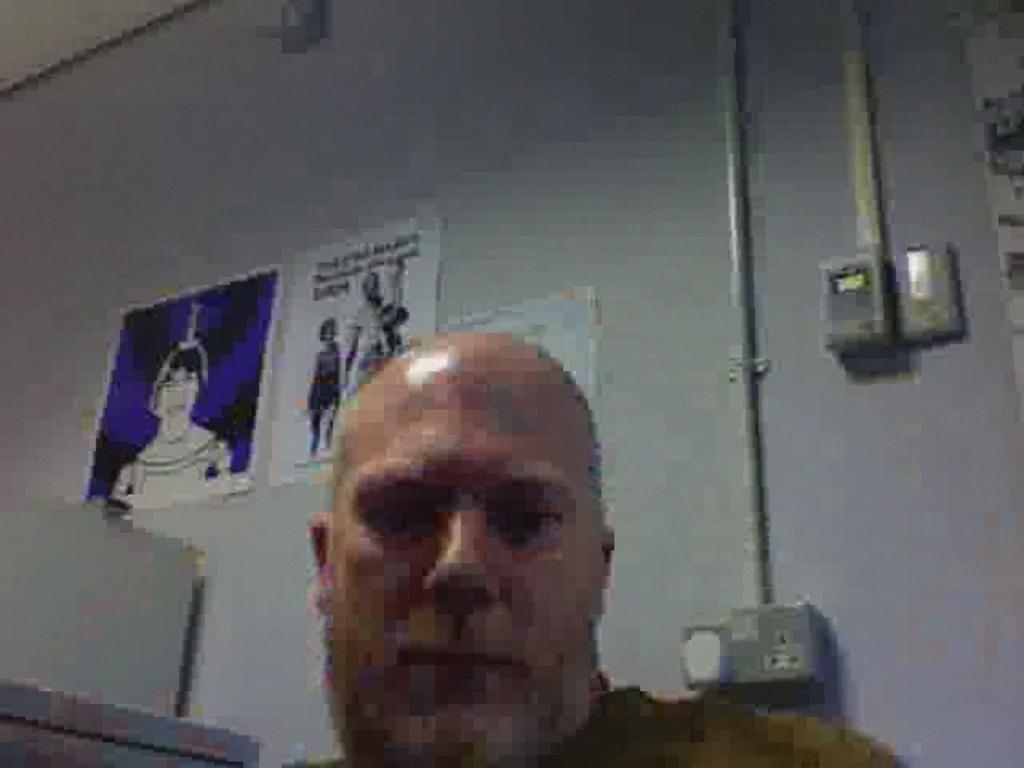Who is present in the image? There is a man in the image. What is the color of the wall in the image? The wall in the image is white. What is attached to the wall? Posters are attached to the wall. Where is the switch board located in the image? The switch board is on the right side of the image. What else can be seen on the right side of the image? Pipes are present on the right side of the image. How much money is being exchanged between the man and the wall in the image? There is no money exchange depicted in the image; it only shows a man, a white wall with posters, a switch board, and pipes. 